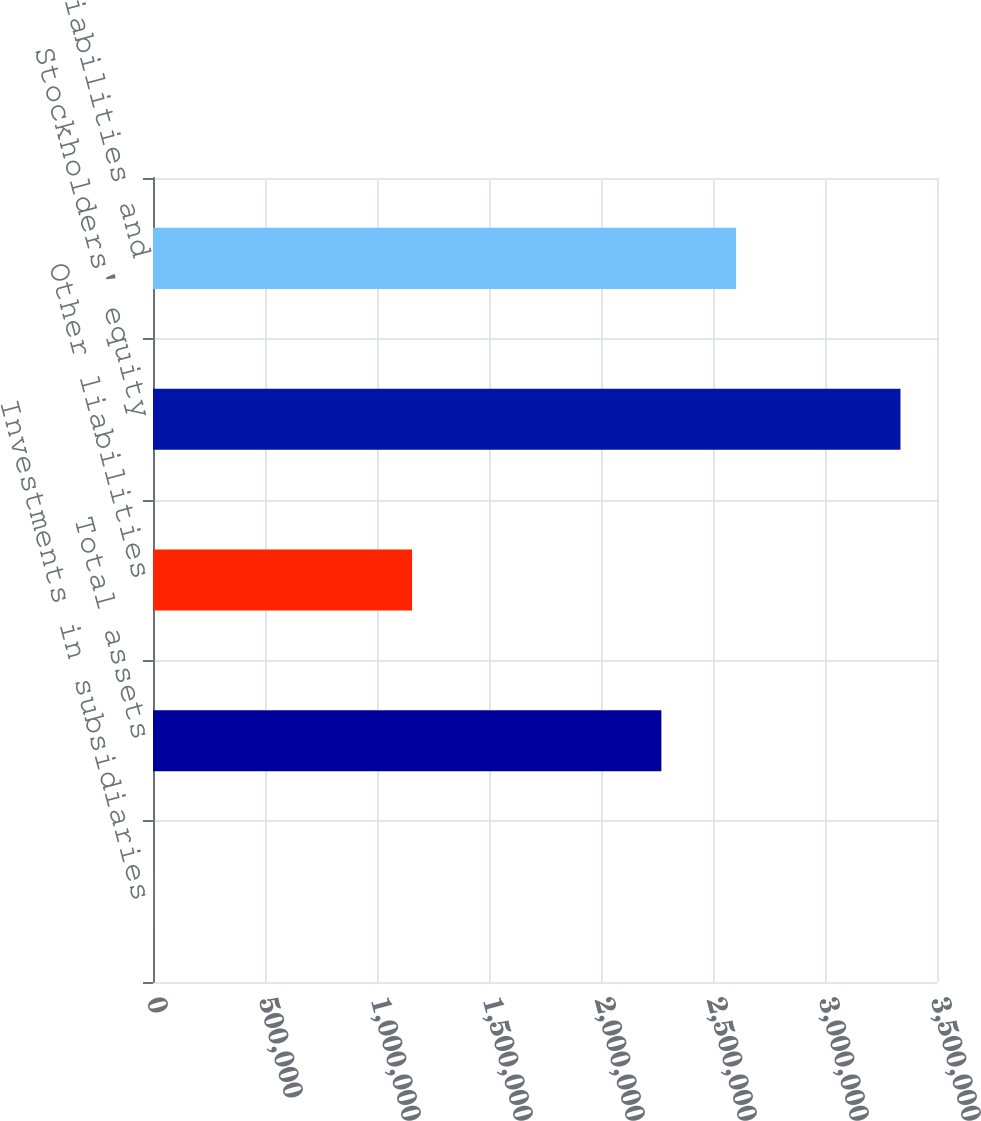Convert chart to OTSL. <chart><loc_0><loc_0><loc_500><loc_500><bar_chart><fcel>Investments in subsidiaries<fcel>Total assets<fcel>Other liabilities<fcel>Stockholders' equity<fcel>Total liabilities and<nl><fcel>449<fcel>2.26953e+06<fcel>1.15658e+06<fcel>3.33699e+06<fcel>2.60319e+06<nl></chart> 